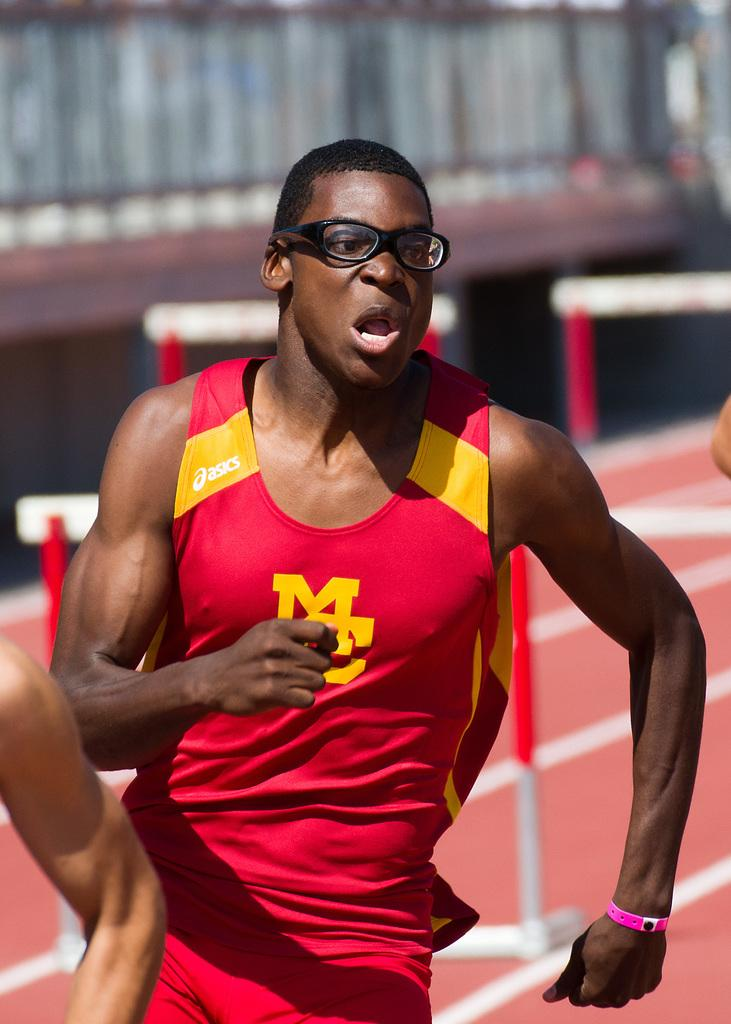<image>
Write a terse but informative summary of the picture. A runner in a race with the letter M on his shirt. 